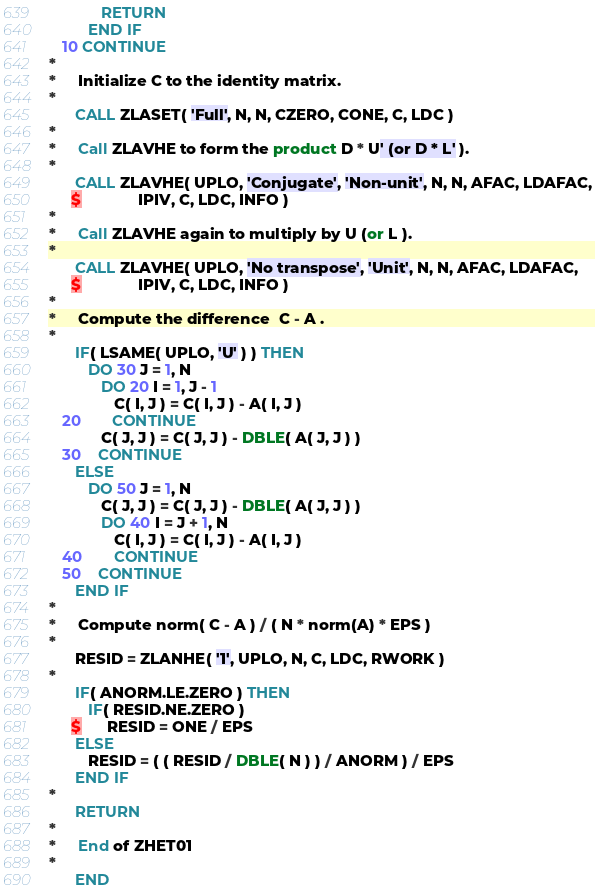<code> <loc_0><loc_0><loc_500><loc_500><_FORTRAN_>            RETURN
         END IF
   10 CONTINUE
*
*     Initialize C to the identity matrix.
*
      CALL ZLASET( 'Full', N, N, CZERO, CONE, C, LDC )
*
*     Call ZLAVHE to form the product D * U' (or D * L' ).
*
      CALL ZLAVHE( UPLO, 'Conjugate', 'Non-unit', N, N, AFAC, LDAFAC,
     $             IPIV, C, LDC, INFO )
*
*     Call ZLAVHE again to multiply by U (or L ).
*
      CALL ZLAVHE( UPLO, 'No transpose', 'Unit', N, N, AFAC, LDAFAC,
     $             IPIV, C, LDC, INFO )
*
*     Compute the difference  C - A .
*
      IF( LSAME( UPLO, 'U' ) ) THEN
         DO 30 J = 1, N
            DO 20 I = 1, J - 1
               C( I, J ) = C( I, J ) - A( I, J )
   20       CONTINUE
            C( J, J ) = C( J, J ) - DBLE( A( J, J ) )
   30    CONTINUE
      ELSE
         DO 50 J = 1, N
            C( J, J ) = C( J, J ) - DBLE( A( J, J ) )
            DO 40 I = J + 1, N
               C( I, J ) = C( I, J ) - A( I, J )
   40       CONTINUE
   50    CONTINUE
      END IF
*
*     Compute norm( C - A ) / ( N * norm(A) * EPS )
*
      RESID = ZLANHE( '1', UPLO, N, C, LDC, RWORK )
*
      IF( ANORM.LE.ZERO ) THEN
         IF( RESID.NE.ZERO )
     $      RESID = ONE / EPS
      ELSE
         RESID = ( ( RESID / DBLE( N ) ) / ANORM ) / EPS
      END IF
*
      RETURN
*
*     End of ZHET01
*
      END
</code> 